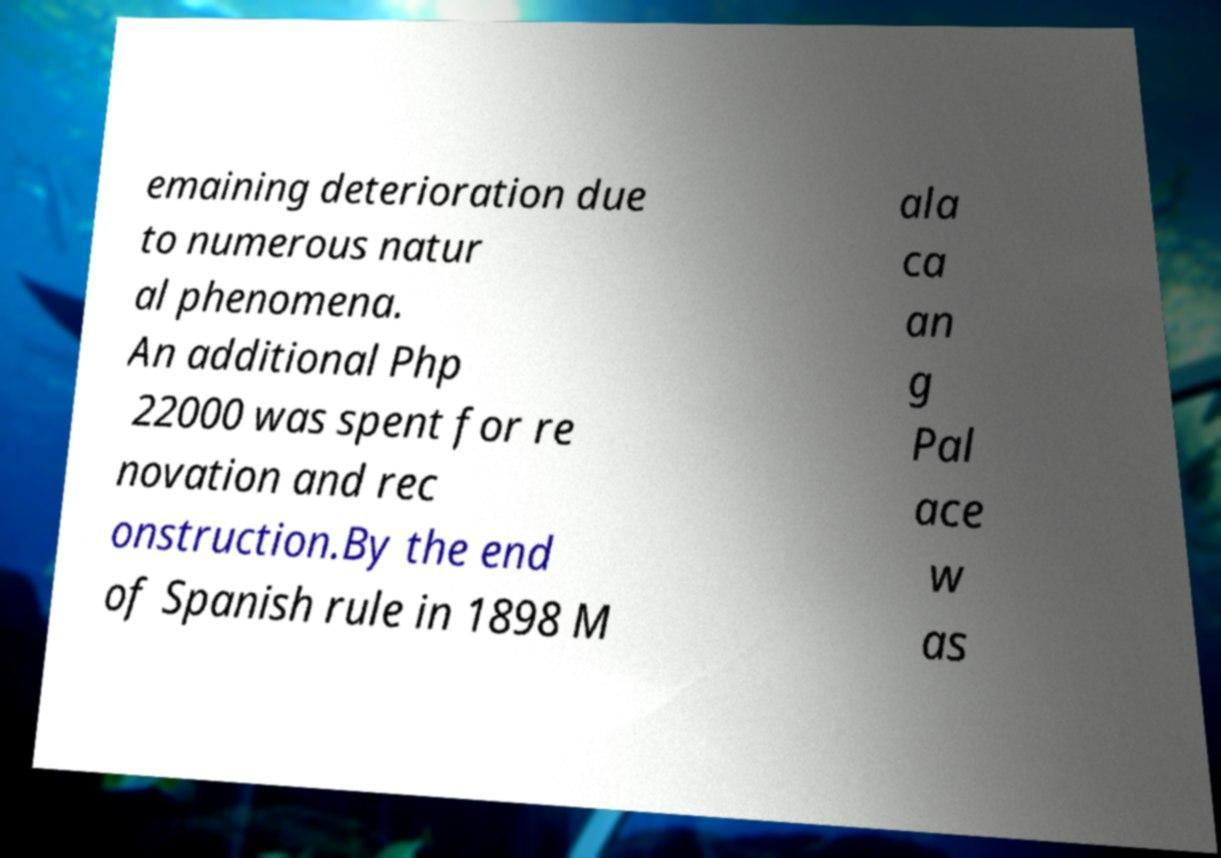For documentation purposes, I need the text within this image transcribed. Could you provide that? emaining deterioration due to numerous natur al phenomena. An additional Php 22000 was spent for re novation and rec onstruction.By the end of Spanish rule in 1898 M ala ca an g Pal ace w as 